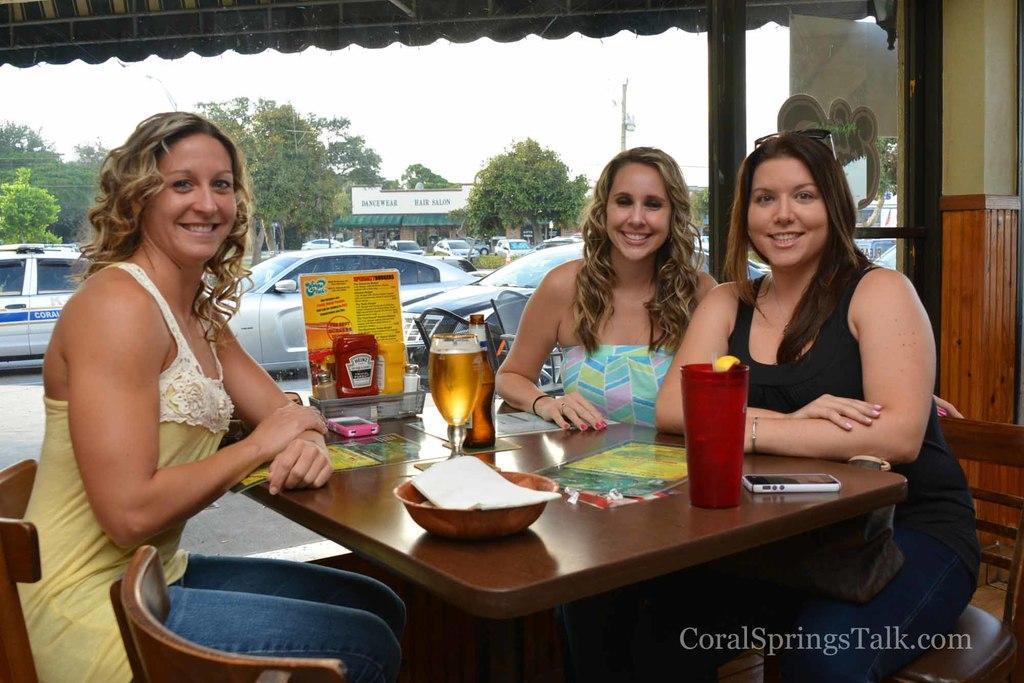Please provide a concise description of this image. People are sitting on the chair and on the table we have glass,phone,bowl,paper, in the back we have trees,car. 